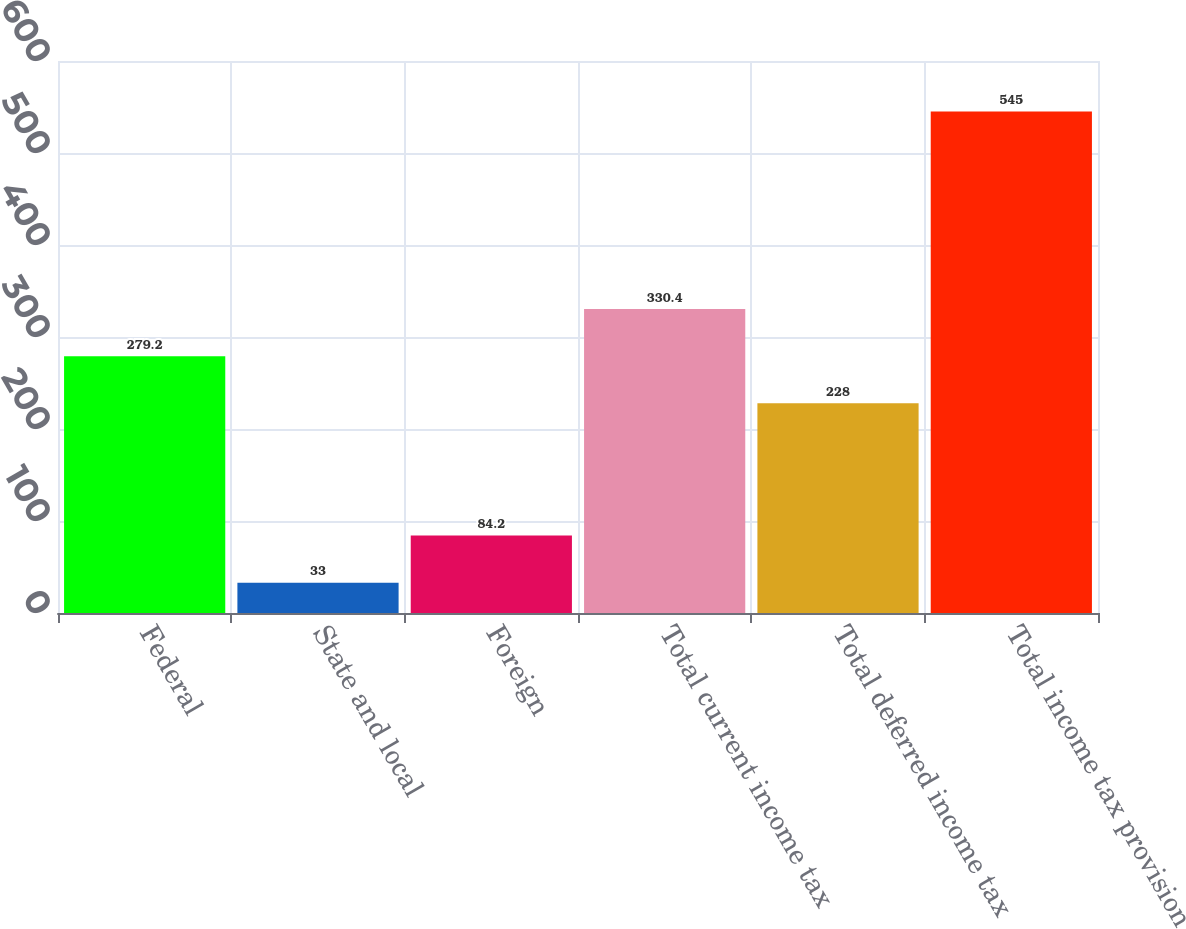Convert chart to OTSL. <chart><loc_0><loc_0><loc_500><loc_500><bar_chart><fcel>Federal<fcel>State and local<fcel>Foreign<fcel>Total current income tax<fcel>Total deferred income tax<fcel>Total income tax provision<nl><fcel>279.2<fcel>33<fcel>84.2<fcel>330.4<fcel>228<fcel>545<nl></chart> 